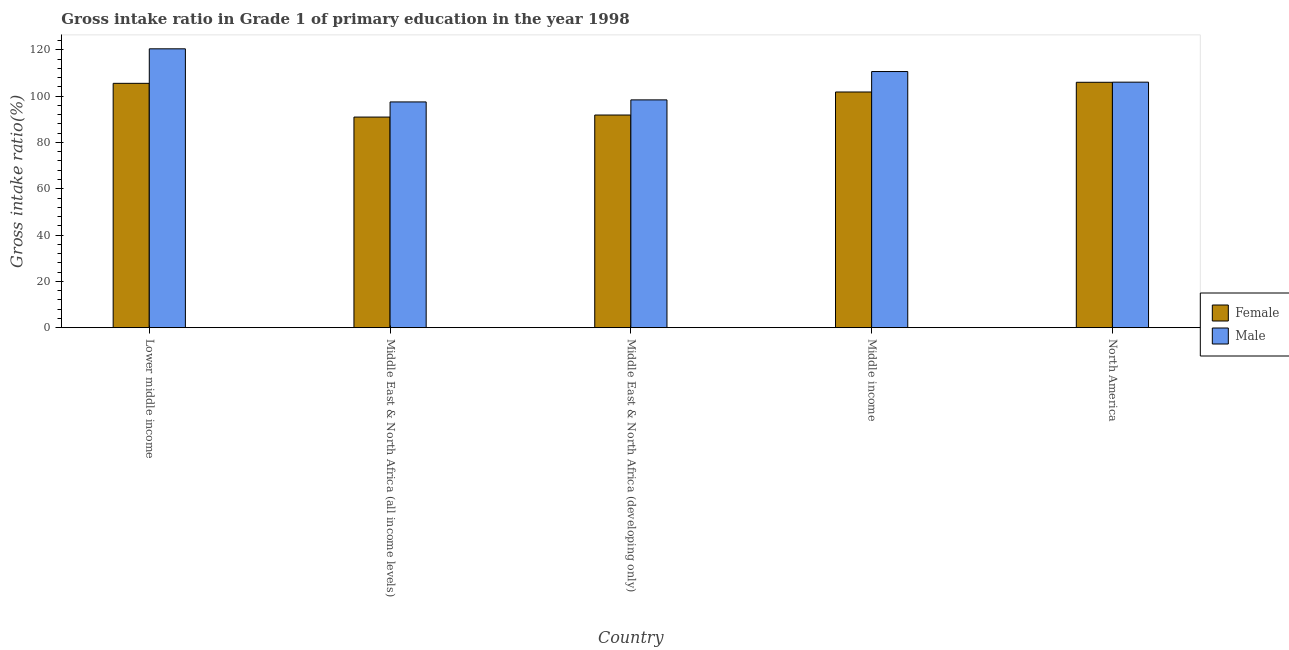Are the number of bars per tick equal to the number of legend labels?
Make the answer very short. Yes. How many bars are there on the 1st tick from the right?
Offer a very short reply. 2. What is the label of the 1st group of bars from the left?
Provide a succinct answer. Lower middle income. What is the gross intake ratio(female) in Lower middle income?
Provide a succinct answer. 105.53. Across all countries, what is the maximum gross intake ratio(female)?
Provide a short and direct response. 105.98. Across all countries, what is the minimum gross intake ratio(female)?
Make the answer very short. 90.97. In which country was the gross intake ratio(female) maximum?
Give a very brief answer. North America. In which country was the gross intake ratio(female) minimum?
Provide a short and direct response. Middle East & North Africa (all income levels). What is the total gross intake ratio(male) in the graph?
Your response must be concise. 533. What is the difference between the gross intake ratio(female) in Lower middle income and that in North America?
Your response must be concise. -0.45. What is the difference between the gross intake ratio(male) in Middle East & North Africa (all income levels) and the gross intake ratio(female) in North America?
Ensure brevity in your answer.  -8.48. What is the average gross intake ratio(female) per country?
Give a very brief answer. 99.23. What is the difference between the gross intake ratio(female) and gross intake ratio(male) in North America?
Your response must be concise. -0.06. In how many countries, is the gross intake ratio(male) greater than 104 %?
Offer a terse response. 3. What is the ratio of the gross intake ratio(female) in Middle income to that in North America?
Your response must be concise. 0.96. Is the gross intake ratio(female) in Middle East & North Africa (developing only) less than that in North America?
Offer a very short reply. Yes. Is the difference between the gross intake ratio(female) in Middle East & North Africa (all income levels) and Middle income greater than the difference between the gross intake ratio(male) in Middle East & North Africa (all income levels) and Middle income?
Your answer should be compact. Yes. What is the difference between the highest and the second highest gross intake ratio(female)?
Give a very brief answer. 0.45. What is the difference between the highest and the lowest gross intake ratio(female)?
Offer a terse response. 15.02. Is the sum of the gross intake ratio(male) in Lower middle income and Middle East & North Africa (developing only) greater than the maximum gross intake ratio(female) across all countries?
Offer a very short reply. Yes. What is the title of the graph?
Offer a terse response. Gross intake ratio in Grade 1 of primary education in the year 1998. Does "Primary" appear as one of the legend labels in the graph?
Keep it short and to the point. No. What is the label or title of the Y-axis?
Your answer should be compact. Gross intake ratio(%). What is the Gross intake ratio(%) in Female in Lower middle income?
Your answer should be compact. 105.53. What is the Gross intake ratio(%) of Male in Lower middle income?
Provide a succinct answer. 120.44. What is the Gross intake ratio(%) in Female in Middle East & North Africa (all income levels)?
Your answer should be very brief. 90.97. What is the Gross intake ratio(%) of Male in Middle East & North Africa (all income levels)?
Offer a terse response. 97.51. What is the Gross intake ratio(%) in Female in Middle East & North Africa (developing only)?
Keep it short and to the point. 91.85. What is the Gross intake ratio(%) of Male in Middle East & North Africa (developing only)?
Provide a succinct answer. 98.38. What is the Gross intake ratio(%) in Female in Middle income?
Your answer should be very brief. 101.79. What is the Gross intake ratio(%) of Male in Middle income?
Your response must be concise. 110.63. What is the Gross intake ratio(%) of Female in North America?
Ensure brevity in your answer.  105.98. What is the Gross intake ratio(%) in Male in North America?
Make the answer very short. 106.04. Across all countries, what is the maximum Gross intake ratio(%) in Female?
Your response must be concise. 105.98. Across all countries, what is the maximum Gross intake ratio(%) of Male?
Your answer should be very brief. 120.44. Across all countries, what is the minimum Gross intake ratio(%) of Female?
Provide a short and direct response. 90.97. Across all countries, what is the minimum Gross intake ratio(%) of Male?
Keep it short and to the point. 97.51. What is the total Gross intake ratio(%) of Female in the graph?
Make the answer very short. 496.13. What is the total Gross intake ratio(%) of Male in the graph?
Offer a terse response. 533. What is the difference between the Gross intake ratio(%) of Female in Lower middle income and that in Middle East & North Africa (all income levels)?
Give a very brief answer. 14.57. What is the difference between the Gross intake ratio(%) of Male in Lower middle income and that in Middle East & North Africa (all income levels)?
Provide a succinct answer. 22.94. What is the difference between the Gross intake ratio(%) of Female in Lower middle income and that in Middle East & North Africa (developing only)?
Your response must be concise. 13.69. What is the difference between the Gross intake ratio(%) in Male in Lower middle income and that in Middle East & North Africa (developing only)?
Make the answer very short. 22.06. What is the difference between the Gross intake ratio(%) in Female in Lower middle income and that in Middle income?
Provide a succinct answer. 3.74. What is the difference between the Gross intake ratio(%) in Male in Lower middle income and that in Middle income?
Keep it short and to the point. 9.82. What is the difference between the Gross intake ratio(%) in Female in Lower middle income and that in North America?
Your answer should be very brief. -0.45. What is the difference between the Gross intake ratio(%) in Male in Lower middle income and that in North America?
Give a very brief answer. 14.4. What is the difference between the Gross intake ratio(%) in Female in Middle East & North Africa (all income levels) and that in Middle East & North Africa (developing only)?
Provide a succinct answer. -0.88. What is the difference between the Gross intake ratio(%) of Male in Middle East & North Africa (all income levels) and that in Middle East & North Africa (developing only)?
Offer a very short reply. -0.88. What is the difference between the Gross intake ratio(%) in Female in Middle East & North Africa (all income levels) and that in Middle income?
Your answer should be very brief. -10.83. What is the difference between the Gross intake ratio(%) in Male in Middle East & North Africa (all income levels) and that in Middle income?
Offer a very short reply. -13.12. What is the difference between the Gross intake ratio(%) of Female in Middle East & North Africa (all income levels) and that in North America?
Provide a short and direct response. -15.02. What is the difference between the Gross intake ratio(%) of Male in Middle East & North Africa (all income levels) and that in North America?
Provide a short and direct response. -8.54. What is the difference between the Gross intake ratio(%) of Female in Middle East & North Africa (developing only) and that in Middle income?
Give a very brief answer. -9.95. What is the difference between the Gross intake ratio(%) of Male in Middle East & North Africa (developing only) and that in Middle income?
Keep it short and to the point. -12.24. What is the difference between the Gross intake ratio(%) in Female in Middle East & North Africa (developing only) and that in North America?
Give a very brief answer. -14.13. What is the difference between the Gross intake ratio(%) of Male in Middle East & North Africa (developing only) and that in North America?
Provide a short and direct response. -7.66. What is the difference between the Gross intake ratio(%) of Female in Middle income and that in North America?
Provide a succinct answer. -4.19. What is the difference between the Gross intake ratio(%) in Male in Middle income and that in North America?
Give a very brief answer. 4.58. What is the difference between the Gross intake ratio(%) of Female in Lower middle income and the Gross intake ratio(%) of Male in Middle East & North Africa (all income levels)?
Your response must be concise. 8.03. What is the difference between the Gross intake ratio(%) in Female in Lower middle income and the Gross intake ratio(%) in Male in Middle East & North Africa (developing only)?
Make the answer very short. 7.15. What is the difference between the Gross intake ratio(%) of Female in Lower middle income and the Gross intake ratio(%) of Male in Middle income?
Offer a very short reply. -5.09. What is the difference between the Gross intake ratio(%) in Female in Lower middle income and the Gross intake ratio(%) in Male in North America?
Your response must be concise. -0.51. What is the difference between the Gross intake ratio(%) in Female in Middle East & North Africa (all income levels) and the Gross intake ratio(%) in Male in Middle East & North Africa (developing only)?
Keep it short and to the point. -7.42. What is the difference between the Gross intake ratio(%) in Female in Middle East & North Africa (all income levels) and the Gross intake ratio(%) in Male in Middle income?
Give a very brief answer. -19.66. What is the difference between the Gross intake ratio(%) in Female in Middle East & North Africa (all income levels) and the Gross intake ratio(%) in Male in North America?
Offer a very short reply. -15.08. What is the difference between the Gross intake ratio(%) of Female in Middle East & North Africa (developing only) and the Gross intake ratio(%) of Male in Middle income?
Your response must be concise. -18.78. What is the difference between the Gross intake ratio(%) of Female in Middle East & North Africa (developing only) and the Gross intake ratio(%) of Male in North America?
Ensure brevity in your answer.  -14.19. What is the difference between the Gross intake ratio(%) of Female in Middle income and the Gross intake ratio(%) of Male in North America?
Make the answer very short. -4.25. What is the average Gross intake ratio(%) of Female per country?
Offer a terse response. 99.23. What is the average Gross intake ratio(%) of Male per country?
Give a very brief answer. 106.6. What is the difference between the Gross intake ratio(%) in Female and Gross intake ratio(%) in Male in Lower middle income?
Your response must be concise. -14.91. What is the difference between the Gross intake ratio(%) in Female and Gross intake ratio(%) in Male in Middle East & North Africa (all income levels)?
Your response must be concise. -6.54. What is the difference between the Gross intake ratio(%) in Female and Gross intake ratio(%) in Male in Middle East & North Africa (developing only)?
Your answer should be compact. -6.54. What is the difference between the Gross intake ratio(%) in Female and Gross intake ratio(%) in Male in Middle income?
Provide a succinct answer. -8.83. What is the difference between the Gross intake ratio(%) of Female and Gross intake ratio(%) of Male in North America?
Your answer should be very brief. -0.06. What is the ratio of the Gross intake ratio(%) of Female in Lower middle income to that in Middle East & North Africa (all income levels)?
Your response must be concise. 1.16. What is the ratio of the Gross intake ratio(%) in Male in Lower middle income to that in Middle East & North Africa (all income levels)?
Provide a succinct answer. 1.24. What is the ratio of the Gross intake ratio(%) of Female in Lower middle income to that in Middle East & North Africa (developing only)?
Offer a very short reply. 1.15. What is the ratio of the Gross intake ratio(%) in Male in Lower middle income to that in Middle East & North Africa (developing only)?
Give a very brief answer. 1.22. What is the ratio of the Gross intake ratio(%) of Female in Lower middle income to that in Middle income?
Your answer should be compact. 1.04. What is the ratio of the Gross intake ratio(%) in Male in Lower middle income to that in Middle income?
Ensure brevity in your answer.  1.09. What is the ratio of the Gross intake ratio(%) in Male in Lower middle income to that in North America?
Give a very brief answer. 1.14. What is the ratio of the Gross intake ratio(%) of Female in Middle East & North Africa (all income levels) to that in Middle East & North Africa (developing only)?
Provide a succinct answer. 0.99. What is the ratio of the Gross intake ratio(%) of Female in Middle East & North Africa (all income levels) to that in Middle income?
Offer a terse response. 0.89. What is the ratio of the Gross intake ratio(%) in Male in Middle East & North Africa (all income levels) to that in Middle income?
Provide a short and direct response. 0.88. What is the ratio of the Gross intake ratio(%) in Female in Middle East & North Africa (all income levels) to that in North America?
Your answer should be compact. 0.86. What is the ratio of the Gross intake ratio(%) in Male in Middle East & North Africa (all income levels) to that in North America?
Your response must be concise. 0.92. What is the ratio of the Gross intake ratio(%) in Female in Middle East & North Africa (developing only) to that in Middle income?
Your answer should be compact. 0.9. What is the ratio of the Gross intake ratio(%) in Male in Middle East & North Africa (developing only) to that in Middle income?
Provide a succinct answer. 0.89. What is the ratio of the Gross intake ratio(%) of Female in Middle East & North Africa (developing only) to that in North America?
Keep it short and to the point. 0.87. What is the ratio of the Gross intake ratio(%) of Male in Middle East & North Africa (developing only) to that in North America?
Make the answer very short. 0.93. What is the ratio of the Gross intake ratio(%) in Female in Middle income to that in North America?
Make the answer very short. 0.96. What is the ratio of the Gross intake ratio(%) in Male in Middle income to that in North America?
Your response must be concise. 1.04. What is the difference between the highest and the second highest Gross intake ratio(%) in Female?
Offer a terse response. 0.45. What is the difference between the highest and the second highest Gross intake ratio(%) of Male?
Your response must be concise. 9.82. What is the difference between the highest and the lowest Gross intake ratio(%) in Female?
Offer a terse response. 15.02. What is the difference between the highest and the lowest Gross intake ratio(%) in Male?
Offer a very short reply. 22.94. 